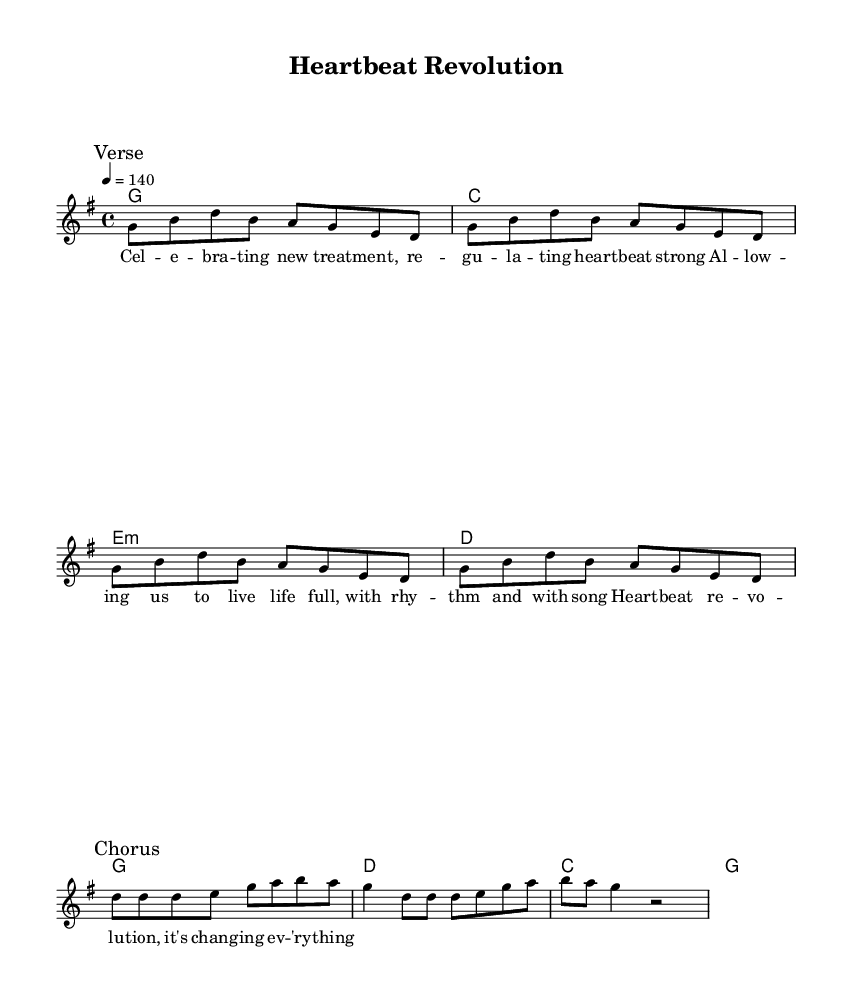What is the key signature of this music? The key signature is G major, which contains an F# and has a total of one sharp.
Answer: G major What is the time signature of this music? The time signature is 4/4, indicating four beats per measure with a quarter note receiving one beat.
Answer: 4/4 What is the tempo marking for this piece? The tempo marking is 140 beats per minute, implying a relatively fast pace for the music.
Answer: 140 What is the function of the chorus in this song? The chorus serves as a focal point, emphasizing the heart revolution theme, contrasting with the verses that set up the narrative.
Answer: Emphasis How many measures are there in the verse section? The verse section consists of two repeated phrases, each containing four measures, resulting in a total of eight measures for the verse.
Answer: 8 What type of chords are used in this piece? The song uses major and minor chords, typical in country rock, which helps create a strong, upbeat feel.
Answer: Major and minor What thematic element is highlighted in the lyrics? The lyrics celebrate medical breakthroughs, specifically focusing on new treatments and their positive impact on life.
Answer: Medical breakthroughs 